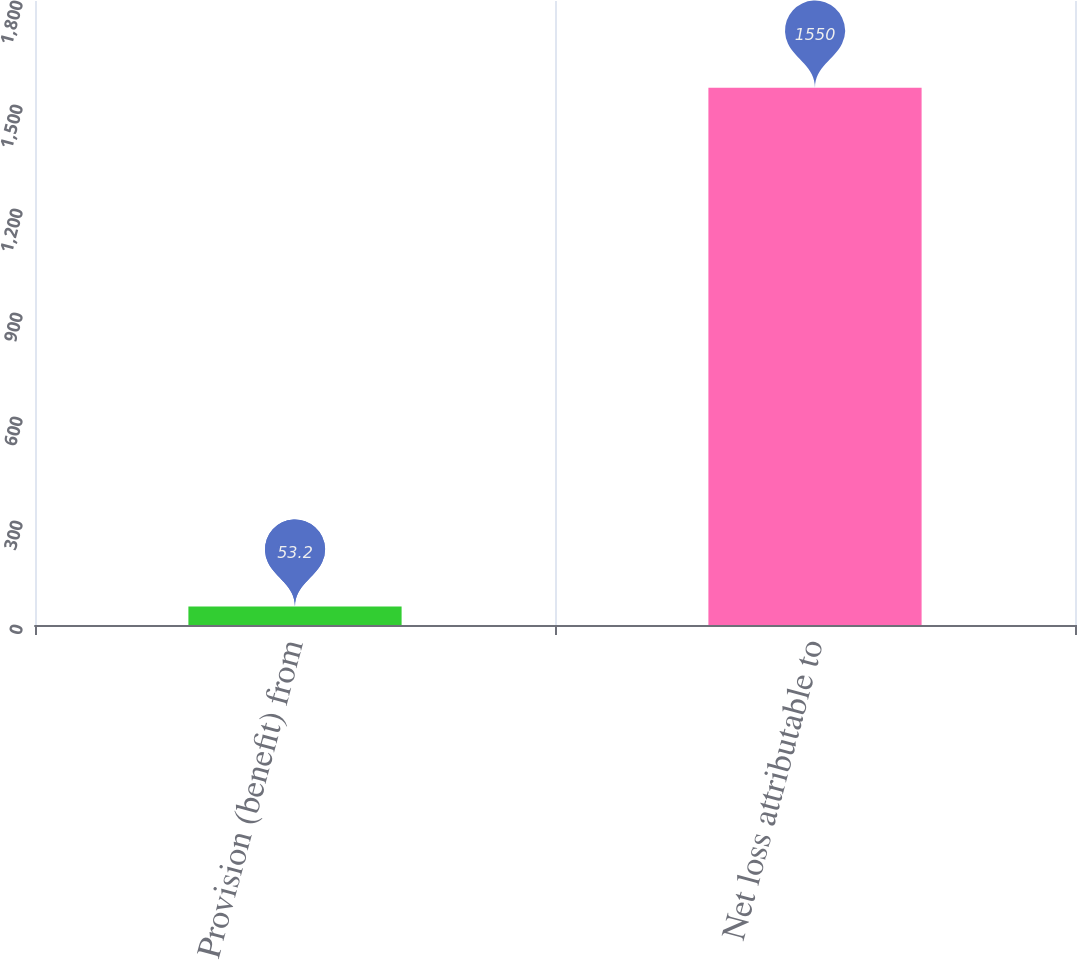<chart> <loc_0><loc_0><loc_500><loc_500><bar_chart><fcel>Provision (benefit) from<fcel>Net loss attributable to<nl><fcel>53.2<fcel>1550<nl></chart> 